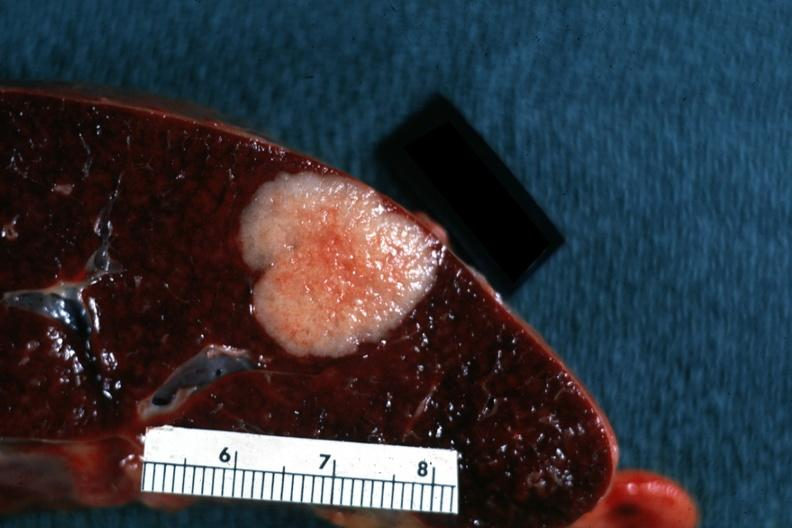what is present?
Answer the question using a single word or phrase. Spleen 